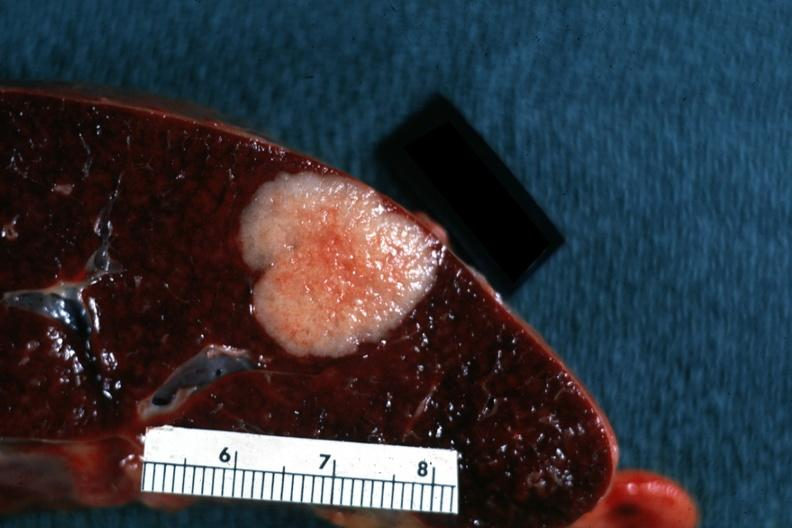what is present?
Answer the question using a single word or phrase. Spleen 